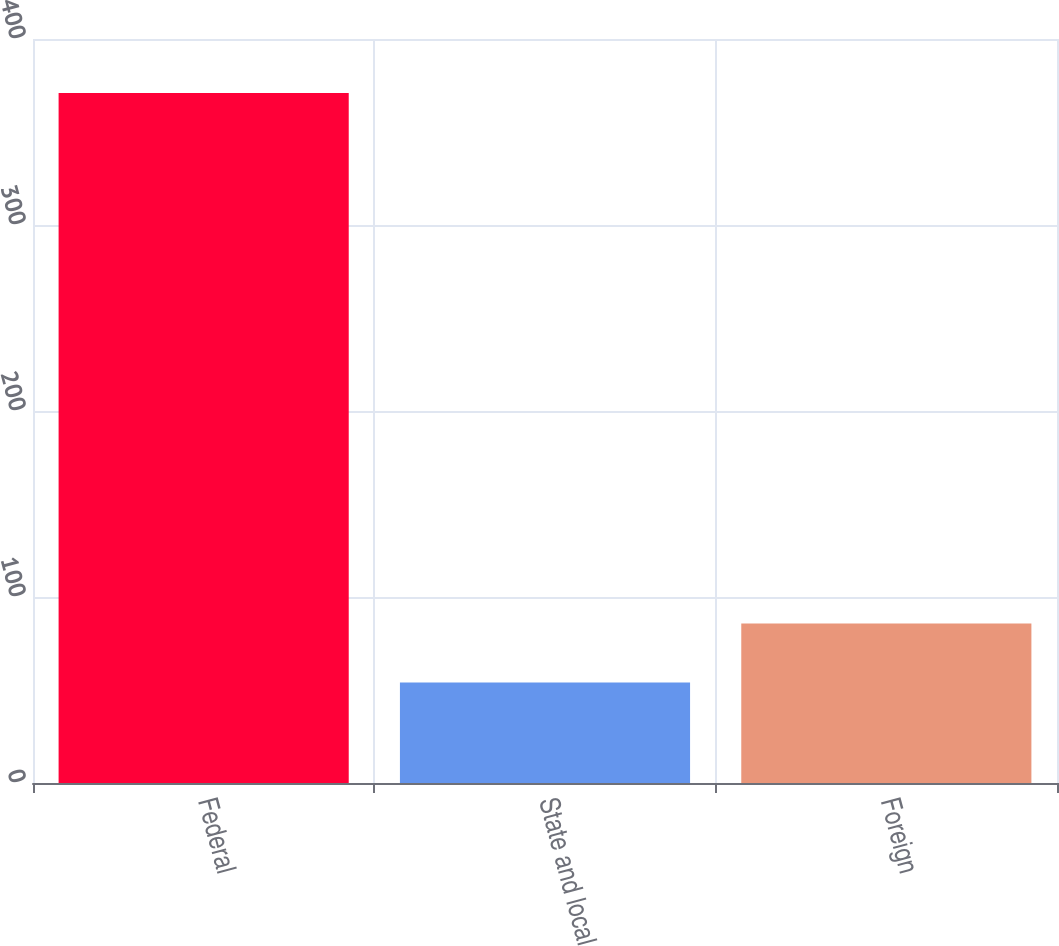Convert chart. <chart><loc_0><loc_0><loc_500><loc_500><bar_chart><fcel>Federal<fcel>State and local<fcel>Foreign<nl><fcel>371<fcel>54<fcel>85.7<nl></chart> 